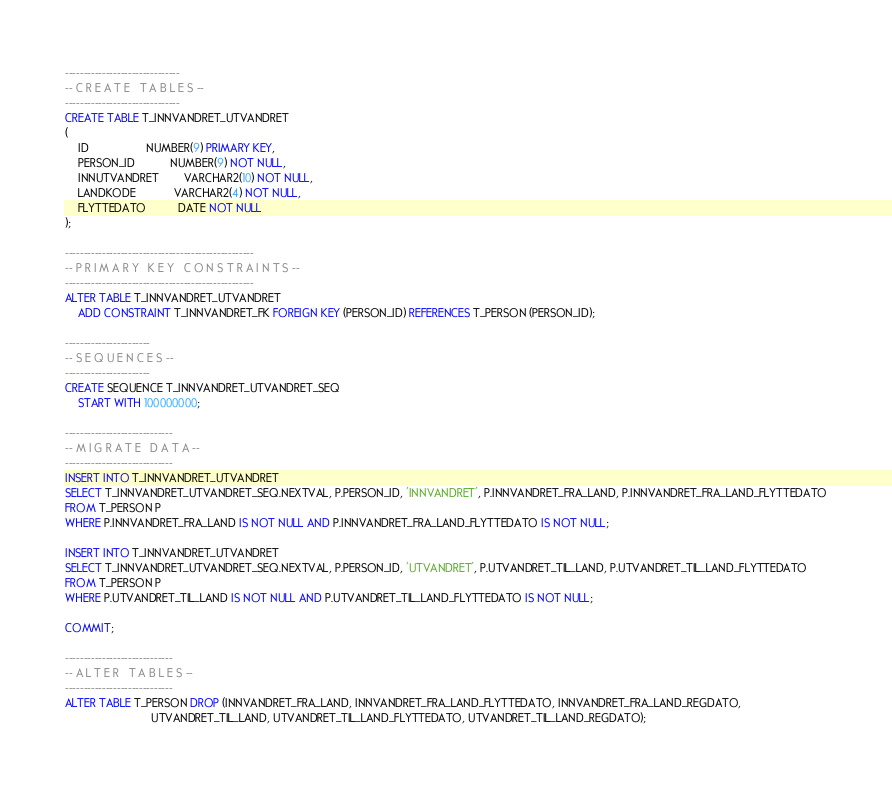<code> <loc_0><loc_0><loc_500><loc_500><_SQL_>-------------------------------
-- C R E A T E   T A B L E S --
-------------------------------
CREATE TABLE T_INNVANDRET_UTVANDRET
(
    ID                  NUMBER(9) PRIMARY KEY,
    PERSON_ID           NUMBER(9) NOT NULL,
    INNUTVANDRET        VARCHAR2(10) NOT NULL,
    LANDKODE            VARCHAR2(4) NOT NULL,
    FLYTTEDATO          DATE NOT NULL
);

---------------------------------------------------
-- P R I M A R Y   K E Y   C O N S T R A I N T S --
---------------------------------------------------
ALTER TABLE T_INNVANDRET_UTVANDRET
    ADD CONSTRAINT T_INNVANDRET_FK FOREIGN KEY (PERSON_ID) REFERENCES T_PERSON (PERSON_ID);

-----------------------
-- S E Q U E N C E S --
-----------------------
CREATE SEQUENCE T_INNVANDRET_UTVANDRET_SEQ
    START WITH 100000000;

-----------------------------
-- M I G R A T E   D A T A --
-----------------------------
INSERT INTO T_INNVANDRET_UTVANDRET
SELECT T_INNVANDRET_UTVANDRET_SEQ.NEXTVAL, P.PERSON_ID, 'INNVANDRET', P.INNVANDRET_FRA_LAND, P.INNVANDRET_FRA_LAND_FLYTTEDATO
FROM T_PERSON P
WHERE P.INNVANDRET_FRA_LAND IS NOT NULL AND P.INNVANDRET_FRA_LAND_FLYTTEDATO IS NOT NULL;

INSERT INTO T_INNVANDRET_UTVANDRET
SELECT T_INNVANDRET_UTVANDRET_SEQ.NEXTVAL, P.PERSON_ID, 'UTVANDRET', P.UTVANDRET_TIL_LAND, P.UTVANDRET_TIL_LAND_FLYTTEDATO
FROM T_PERSON P
WHERE P.UTVANDRET_TIL_LAND IS NOT NULL AND P.UTVANDRET_TIL_LAND_FLYTTEDATO IS NOT NULL;

COMMIT;

-----------------------------
-- A L T E R   T A B L E S --
-----------------------------
ALTER TABLE T_PERSON DROP (INNVANDRET_FRA_LAND, INNVANDRET_FRA_LAND_FLYTTEDATO, INNVANDRET_FRA_LAND_REGDATO,
                           UTVANDRET_TIL_LAND, UTVANDRET_TIL_LAND_FLYTTEDATO, UTVANDRET_TIL_LAND_REGDATO);</code> 